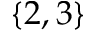<formula> <loc_0><loc_0><loc_500><loc_500>\{ 2 , 3 \}</formula> 